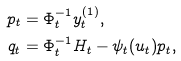Convert formula to latex. <formula><loc_0><loc_0><loc_500><loc_500>p _ { t } & = \Phi _ { t } ^ { - 1 } y ^ { ( 1 ) } _ { t } , \\ q _ { t } & = \Phi _ { t } ^ { - 1 } H _ { t } - \psi _ { t } ( u _ { t } ) p _ { t } ,</formula> 